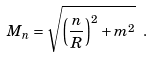<formula> <loc_0><loc_0><loc_500><loc_500>M _ { n } = \sqrt { \left ( \frac { n } { R } \right ) ^ { 2 } + m ^ { 2 } } \ .</formula> 